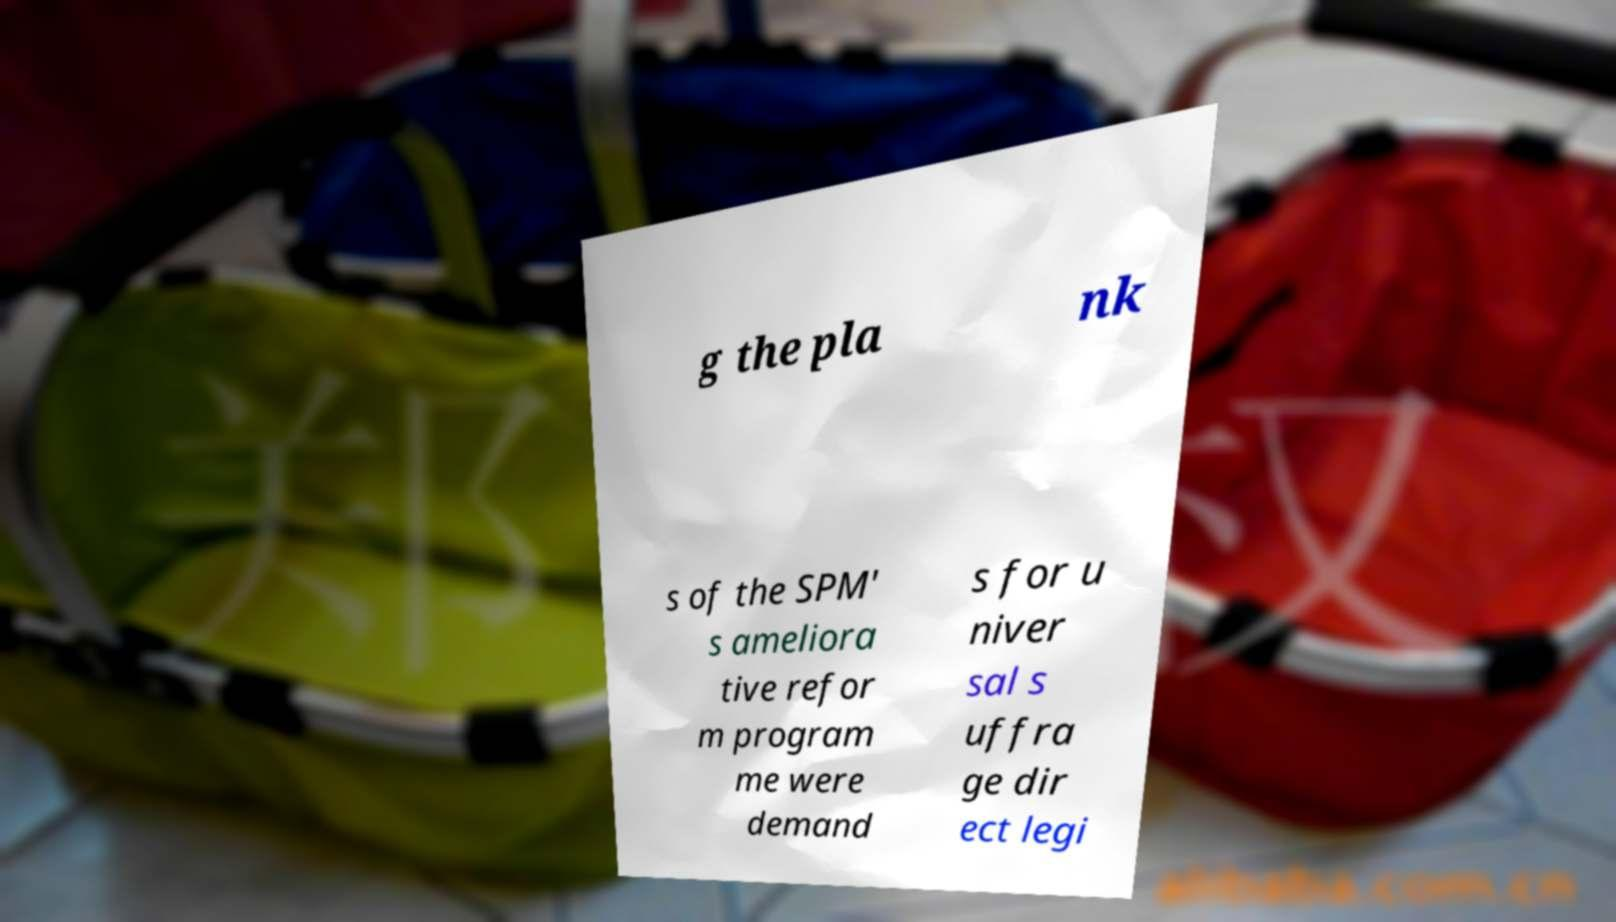Can you read and provide the text displayed in the image?This photo seems to have some interesting text. Can you extract and type it out for me? g the pla nk s of the SPM' s ameliora tive refor m program me were demand s for u niver sal s uffra ge dir ect legi 